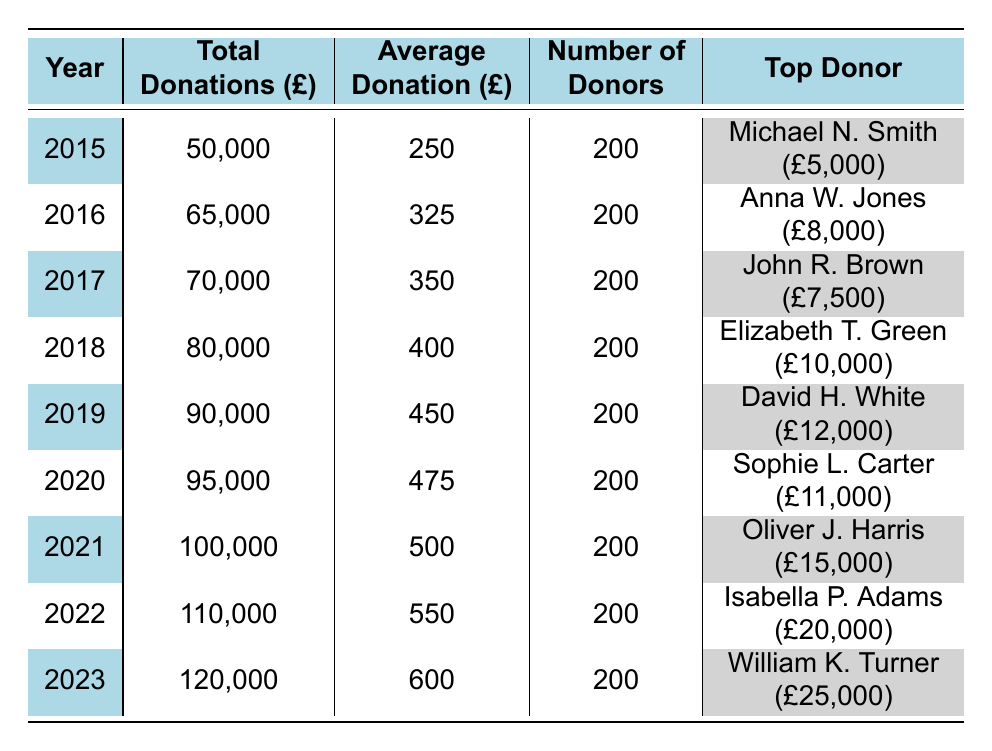What was the total amount of donations in 2020? The table shows that in 2020, the total donations amounted to £95,000.
Answer: £95,000 Who was the top donor in 2021? In 2021, the top donor was Oliver J. Harris, who donated £15,000.
Answer: Oliver J. Harris What is the average donation amount in 2022? The average donation amount for 2022 is given in the table as £550.
Answer: £550 How many donors contributed in 2019? According to the table, the number of donors in 2019 was 200.
Answer: 200 What was the increase in total donations from 2018 to 2019? The total donations in 2018 were £80,000, and in 2019 they were £90,000. The increase is £90,000 - £80,000 = £10,000.
Answer: £10,000 Is the average donation amount higher in 2023 than in 2021? The average donation in 2023 is £600, and in 2021 it is £500. Since £600 > £500, the statement is true.
Answer: Yes What was the total amount of donations from 2015 to 2018? To find the total donations, we sum the amounts: £50,000 + £65,000 + £70,000 + £80,000 = £265,000.
Answer: £265,000 Identify the year with the highest average donation. By comparing the average donations from each year in the table, we see that 2023 has the highest average donation of £600.
Answer: 2023 What is the difference in the number of donors between 2015 and 2022? The number of donors is consistent at 200 for both years, therefore, the difference is 200 - 200 = 0.
Answer: 0 Which alumnus donated the highest amount from 2015 to 2023? The table shows that William K. Turner donated the highest amount of £25,000 in 2023, more than any other top donor in the previous years.
Answer: William K. Turner 